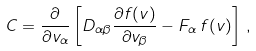<formula> <loc_0><loc_0><loc_500><loc_500>C = \frac { \partial } { \partial v _ { \alpha } } \left [ D _ { \alpha \beta } \frac { \partial f ( v ) } { \partial v _ { \beta } } - F _ { \alpha } \, f ( v ) \right ] \, ,</formula> 